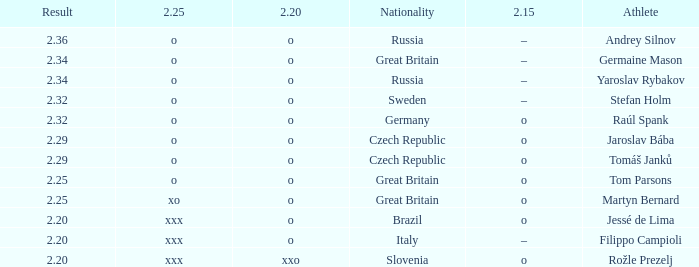Which athlete from Germany has 2.20 of O and a 2.25 of O? Raúl Spank. 